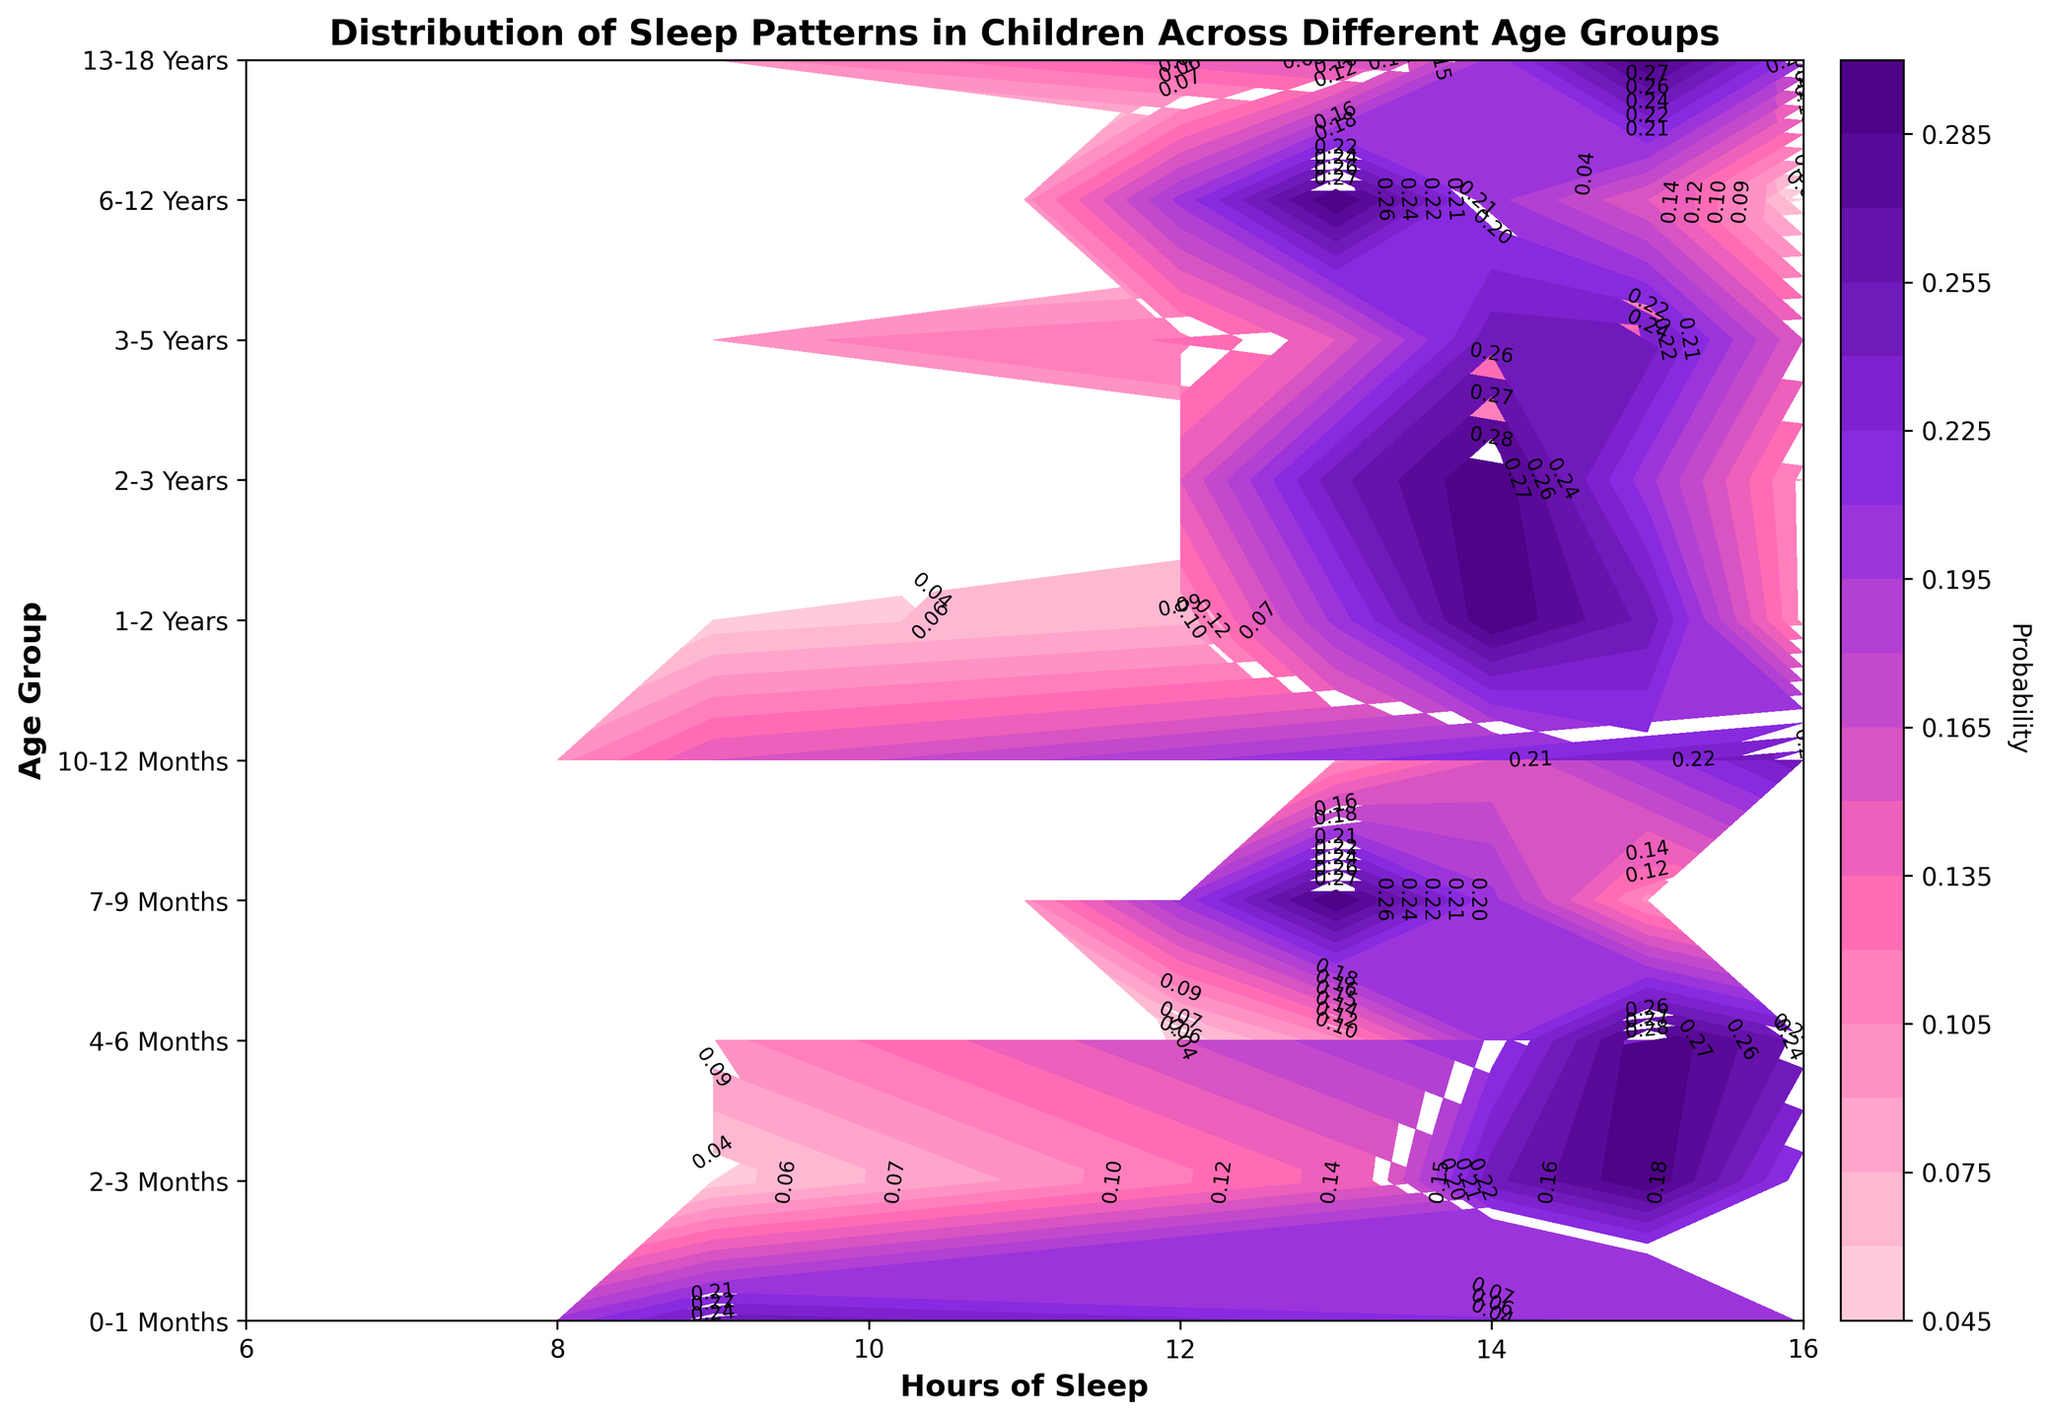What's the title of the figure? The title of the figure is typically found at the top center of the plot area. In this plot, the title "Distribution of Sleep Patterns in Children Across Different Age Groups" is clearly indicated.
Answer: Distribution of Sleep Patterns in Children Across Different Age Groups How do the axis labels describe the data? The x-axis label "Hours of Sleep" represents the different quantities of sleep, while the y-axis label "Age Group" indicates the different age ranges of children. These labels help to pinpoint what data each axis contains.
Answer: Hours of Sleep and Age Group What age group has the highest probability for 11 hours of sleep? To find this information, scan along the x-axis to the value "11" for Hours of Sleep and then look at the y-axis to see which age group is at the highest contour level indicated by the color gradient or labels.
Answer: 7-9 Months Which age group covers the widest range of sleep hours with significant probability? Identify the age group that spans the most hours of sleep with notable (high probability) contour lines. The boldest colors and higher probabilities show wider sleep hour distributions.
Answer: 0-1 Months What is the general trend of sleep hours as age increases? By observing the main contour gradients from left to right, note how the sleep hours change across different age groups on the y-axis. As children get older, the hours of sleep fewer and shift to lower probabilities.
Answer: Sleep hours generally decrease as age increases Which age group has the highest probability of sleeping exactly 10 hours? Examine the contour levels along the line representing 10 hours of sleep on the x-axis and determine where the probability is highest. The 0-1 Months age group has a high probability, but 4-6 Months shows a peak.
Answer: 1-2 Years How does the contour pattern change between 4-6 months and 7-9 months? Compare the contours of these two age ranges across the varying hours of sleep. Look for changes in peak probabilities, color gradients, and the distribution’s shape between the adjacent age groups.
Answer: The peak probability shifts towards lower hours of sleep, and the distribution becomes less spread out At what sleep hour does the 6-12 Years group have the highest probability? Focus on the contour lines within the 6-12 Years age section and look for the highest probability color or contour labeling. Trace from the y-axis to the corresponding x-value.
Answer: 9 hours What is the probability range for the 2-3 Years age group having 10 hours of sleep? Look at the contour graph and identify the contour labels or color gradients for the specific age group and sleep hour. This will show the minimum and maximum probabilities.
Answer: 0.20 to 0.30 What sleep hour is most probable for teenagers (13-18 years)? Locate the 13-18 Years age group on the y-axis and follow the contour lines to see which sleep hour intersects with the highest probability.
Answer: 9 hours 